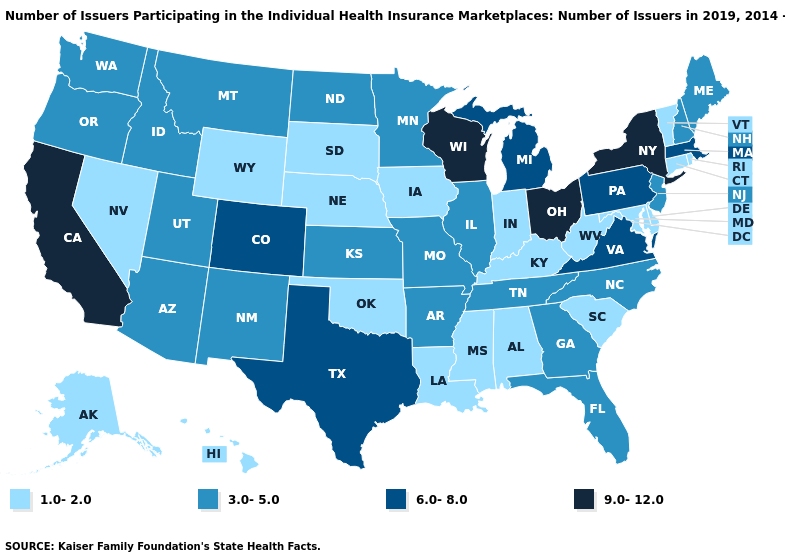What is the value of Missouri?
Write a very short answer. 3.0-5.0. Among the states that border New Hampshire , does Massachusetts have the highest value?
Write a very short answer. Yes. How many symbols are there in the legend?
Quick response, please. 4. What is the highest value in the USA?
Be succinct. 9.0-12.0. What is the lowest value in the USA?
Short answer required. 1.0-2.0. How many symbols are there in the legend?
Write a very short answer. 4. What is the value of South Carolina?
Keep it brief. 1.0-2.0. Does Massachusetts have the highest value in the Northeast?
Write a very short answer. No. Which states have the lowest value in the USA?
Keep it brief. Alabama, Alaska, Connecticut, Delaware, Hawaii, Indiana, Iowa, Kentucky, Louisiana, Maryland, Mississippi, Nebraska, Nevada, Oklahoma, Rhode Island, South Carolina, South Dakota, Vermont, West Virginia, Wyoming. Does the first symbol in the legend represent the smallest category?
Short answer required. Yes. Among the states that border New Jersey , does New York have the highest value?
Answer briefly. Yes. Does Indiana have a lower value than Rhode Island?
Write a very short answer. No. What is the lowest value in the USA?
Concise answer only. 1.0-2.0. Does the first symbol in the legend represent the smallest category?
Answer briefly. Yes. Name the states that have a value in the range 9.0-12.0?
Answer briefly. California, New York, Ohio, Wisconsin. 